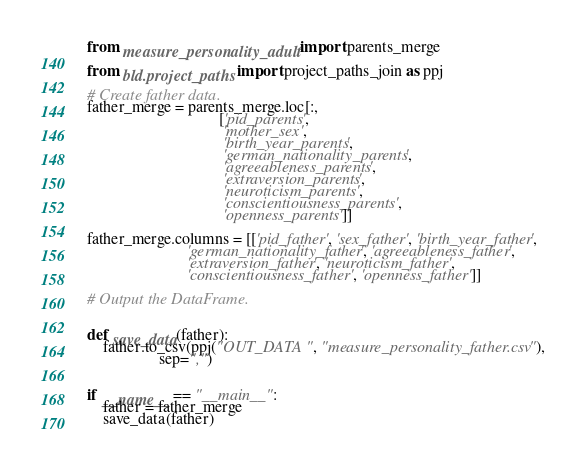Convert code to text. <code><loc_0><loc_0><loc_500><loc_500><_Python_>from measure_personality_adult import parents_merge

from bld.project_paths import project_paths_join as ppj

# Create father data.
father_merge = parents_merge.loc[:,
                                 ['pid_parents',
                                  'mother_sex',
                                  'birth_year_parents',
                                  'german_nationality_parents',
                                  'agreeableness_parents',
                                  'extraversion_parents',
                                  'neuroticism_parents',
                                  'conscientiousness_parents',
                                  'openness_parents']]

father_merge.columns = [['pid_father', 'sex_father', 'birth_year_father',
                         'german_nationality_father', 'agreeableness_father',
                         'extraversion_father', 'neuroticism_father',
                         'conscientiousness_father', 'openness_father']]

# Output the DataFrame.


def save_data(father):
    father.to_csv(ppj("OUT_DATA", "measure_personality_father.csv"),
                  sep=",")


if __name__ == "__main__":
    father = father_merge
    save_data(father)
</code> 